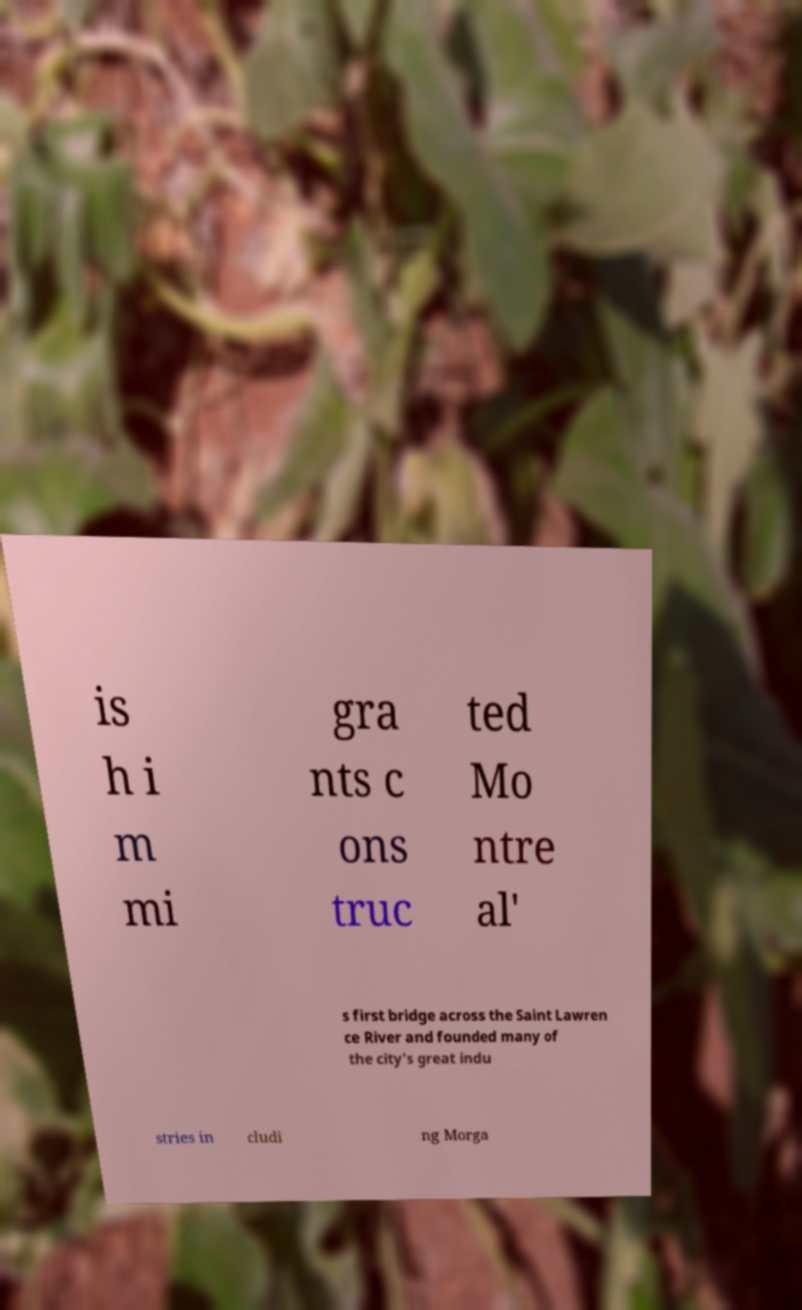There's text embedded in this image that I need extracted. Can you transcribe it verbatim? is h i m mi gra nts c ons truc ted Mo ntre al' s first bridge across the Saint Lawren ce River and founded many of the city's great indu stries in cludi ng Morga 